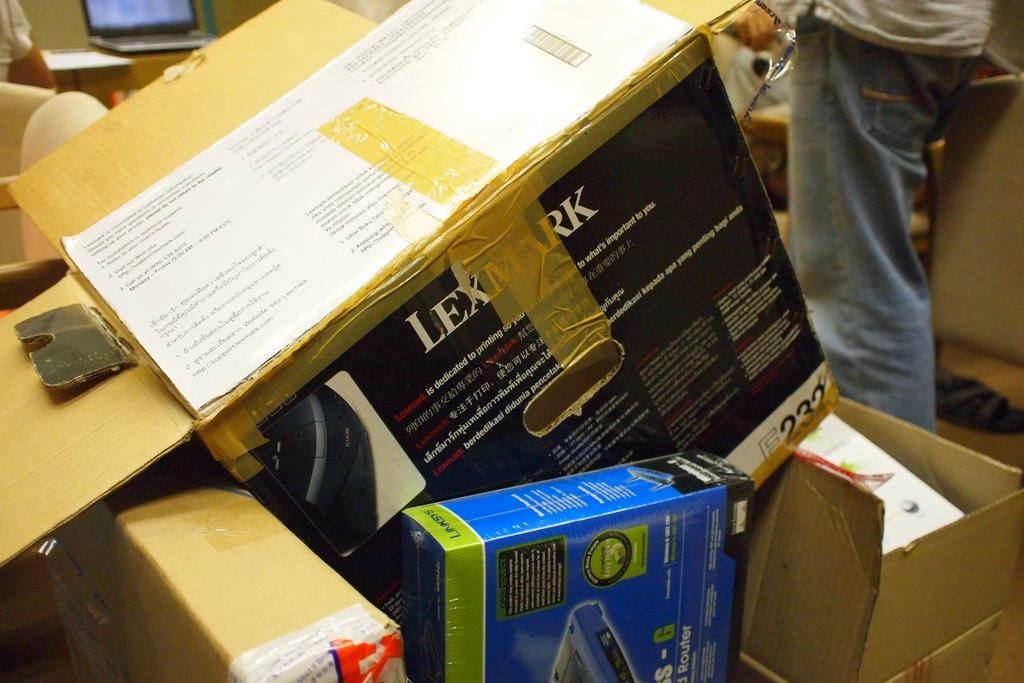What type of objects are present in the image? There are cardboard boxes in the image. Can you describe the person's position in relation to the cardboard boxes? There is a person on the right side of the cardboard boxes. What electronic device can be seen in the image? There is a laptop in the top left corner of the image. What type of channel is the person watching on the laptop in the image? There is no indication in the image that the person is watching a channel on the laptop. Is there any popcorn visible in the image? There is no popcorn present in the image. 